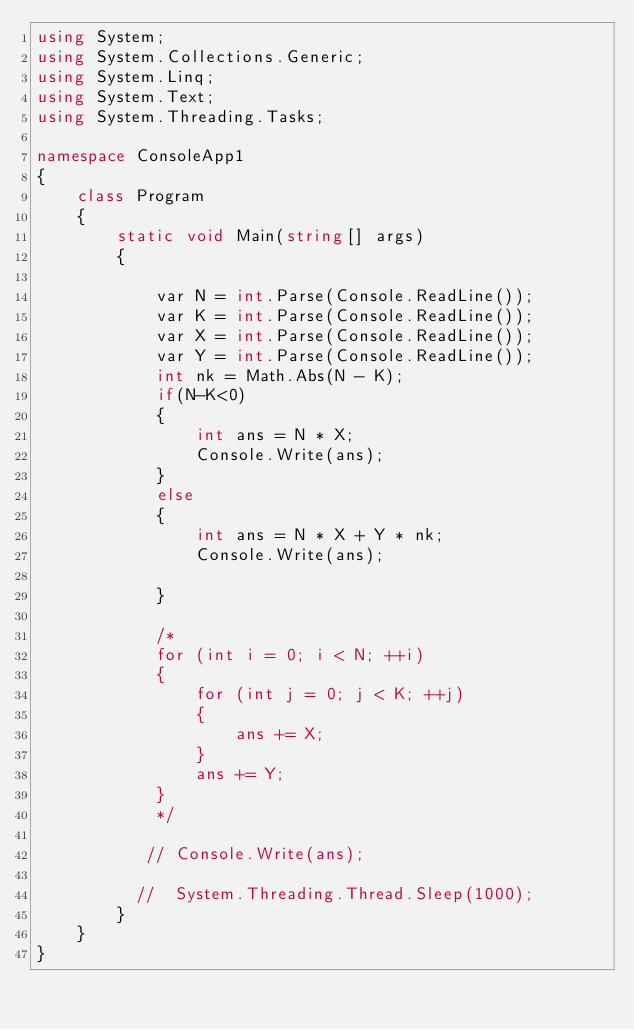Convert code to text. <code><loc_0><loc_0><loc_500><loc_500><_C#_>using System;
using System.Collections.Generic;
using System.Linq;
using System.Text;
using System.Threading.Tasks;

namespace ConsoleApp1
{
    class Program
    {
        static void Main(string[] args)
        {

            var N = int.Parse(Console.ReadLine());
            var K = int.Parse(Console.ReadLine());
            var X = int.Parse(Console.ReadLine());
            var Y = int.Parse(Console.ReadLine());
            int nk = Math.Abs(N - K);
            if(N-K<0)
            {
                int ans = N * X;
                Console.Write(ans);
            }
            else
            {
                int ans = N * X + Y * nk;
                Console.Write(ans);

            }

            /*
            for (int i = 0; i < N; ++i)
            {
                for (int j = 0; j < K; ++j)
                {
                    ans += X;
                }
                ans += Y;
            }
            */

           // Console.Write(ans);

          //  System.Threading.Thread.Sleep(1000);
        }
    }
}
</code> 